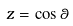<formula> <loc_0><loc_0><loc_500><loc_500>z = \cos \theta</formula> 